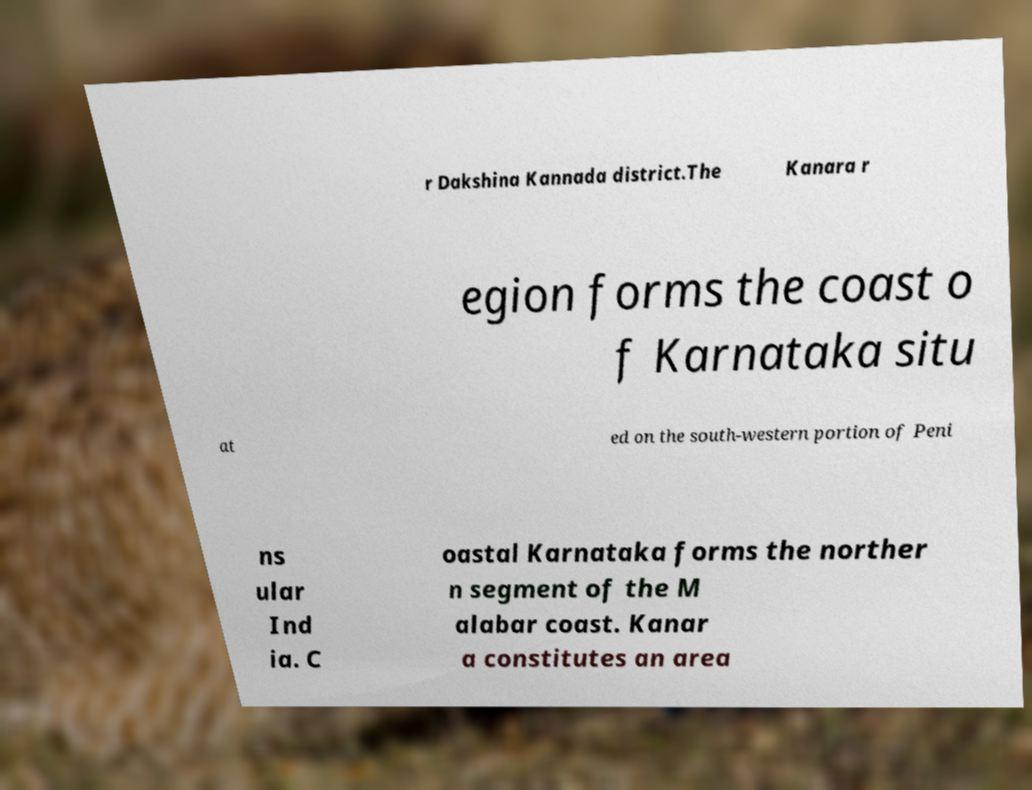For documentation purposes, I need the text within this image transcribed. Could you provide that? r Dakshina Kannada district.The Kanara r egion forms the coast o f Karnataka situ at ed on the south-western portion of Peni ns ular Ind ia. C oastal Karnataka forms the norther n segment of the M alabar coast. Kanar a constitutes an area 